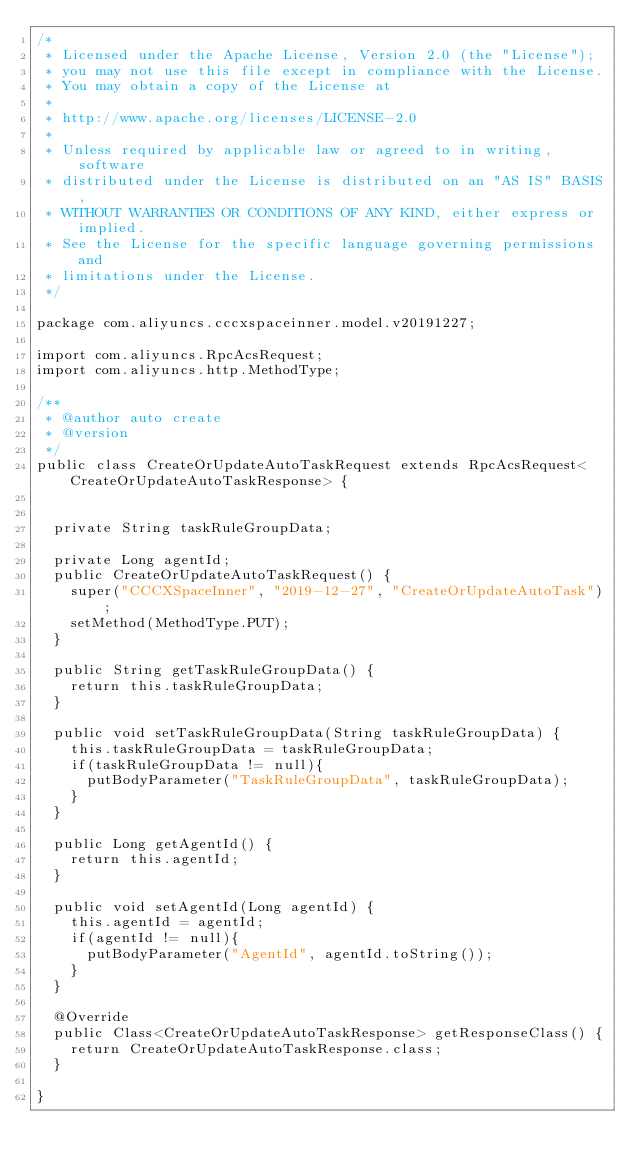Convert code to text. <code><loc_0><loc_0><loc_500><loc_500><_Java_>/*
 * Licensed under the Apache License, Version 2.0 (the "License");
 * you may not use this file except in compliance with the License.
 * You may obtain a copy of the License at
 *
 * http://www.apache.org/licenses/LICENSE-2.0
 *
 * Unless required by applicable law or agreed to in writing, software
 * distributed under the License is distributed on an "AS IS" BASIS,
 * WITHOUT WARRANTIES OR CONDITIONS OF ANY KIND, either express or implied.
 * See the License for the specific language governing permissions and
 * limitations under the License.
 */

package com.aliyuncs.cccxspaceinner.model.v20191227;

import com.aliyuncs.RpcAcsRequest;
import com.aliyuncs.http.MethodType;

/**
 * @author auto create
 * @version 
 */
public class CreateOrUpdateAutoTaskRequest extends RpcAcsRequest<CreateOrUpdateAutoTaskResponse> {
	   

	private String taskRuleGroupData;

	private Long agentId;
	public CreateOrUpdateAutoTaskRequest() {
		super("CCCXSpaceInner", "2019-12-27", "CreateOrUpdateAutoTask");
		setMethod(MethodType.PUT);
	}

	public String getTaskRuleGroupData() {
		return this.taskRuleGroupData;
	}

	public void setTaskRuleGroupData(String taskRuleGroupData) {
		this.taskRuleGroupData = taskRuleGroupData;
		if(taskRuleGroupData != null){
			putBodyParameter("TaskRuleGroupData", taskRuleGroupData);
		}
	}

	public Long getAgentId() {
		return this.agentId;
	}

	public void setAgentId(Long agentId) {
		this.agentId = agentId;
		if(agentId != null){
			putBodyParameter("AgentId", agentId.toString());
		}
	}

	@Override
	public Class<CreateOrUpdateAutoTaskResponse> getResponseClass() {
		return CreateOrUpdateAutoTaskResponse.class;
	}

}
</code> 